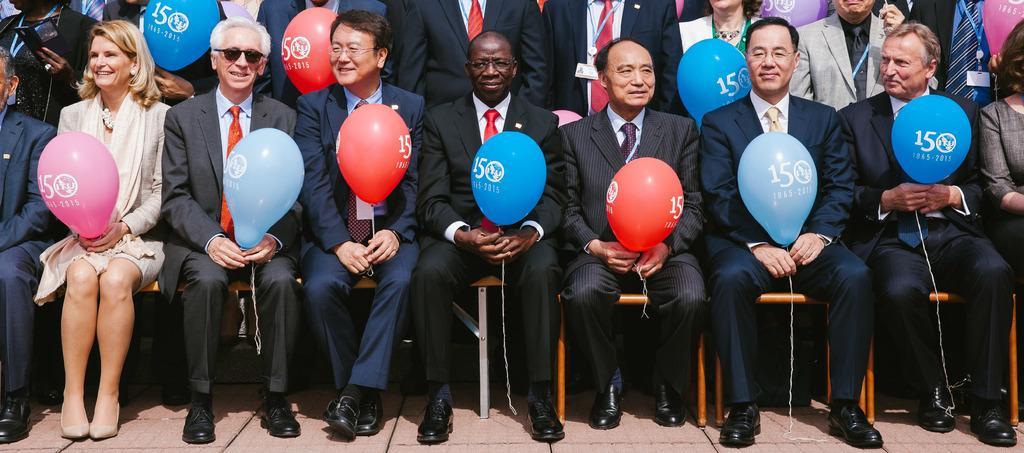How would you summarize this image in a sentence or two? In this picture there are people, among them few people holding balloons and we can see ground. 